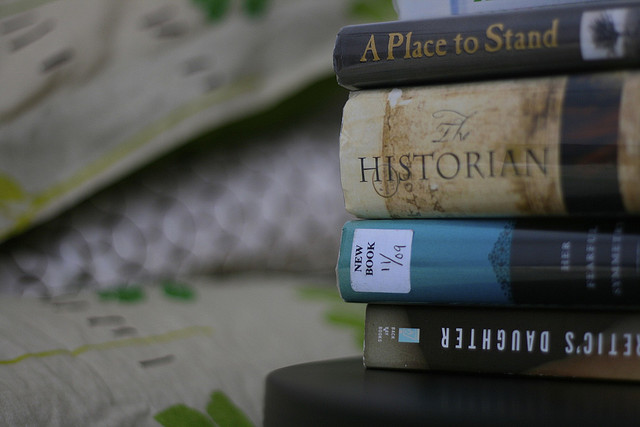Read all the text in this image. Place A HISTORIAN DAUGHTER 